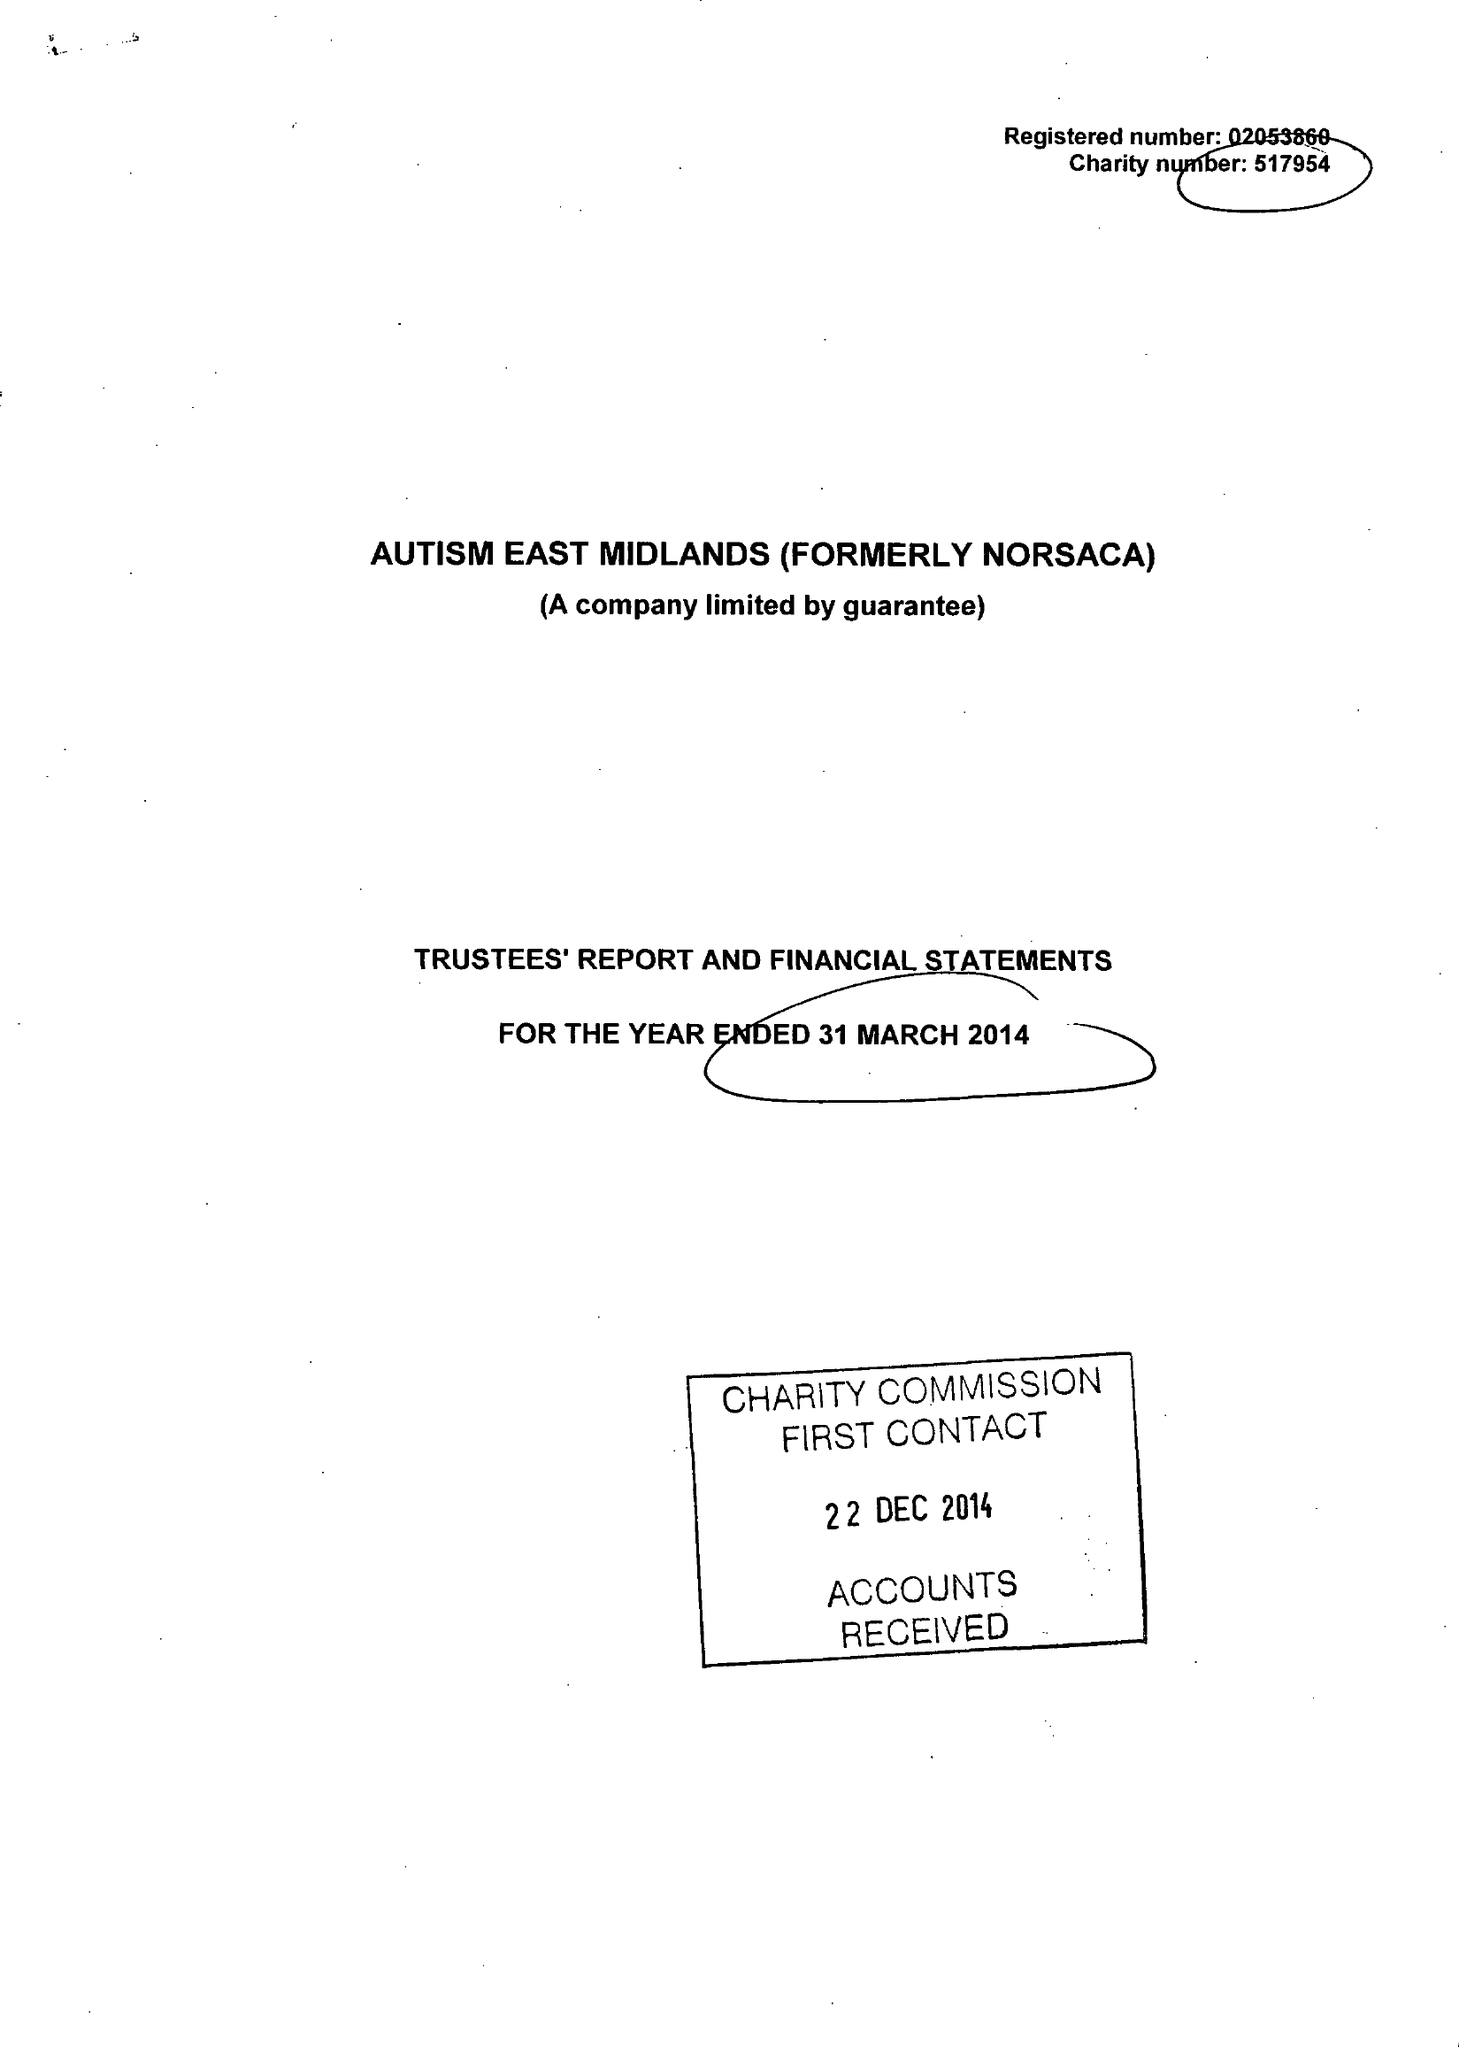What is the value for the income_annually_in_british_pounds?
Answer the question using a single word or phrase. 11956233.00 